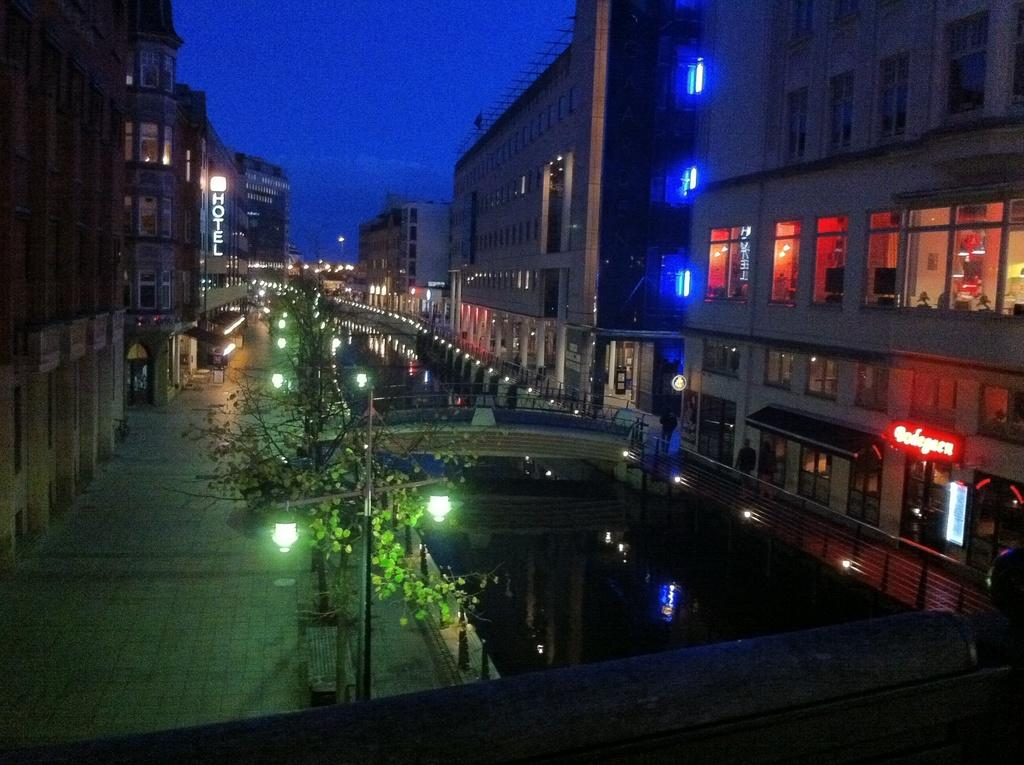What type of structures can be seen in the image? There are buildings in the image. What natural element is visible in the image? There is water visible in the image. What type of vegetation is present in the image? There are trees in the image. Can you describe a man-made object in the image? There is a pole in the image. What type of signage is present in the image? There are boards in the image. What type of illumination is present in the image? There are lights in the image. What type of infrastructure is present in the image? There is a bridge in the image. What is the color of the sky in the image? The sky is blue in the image. What type of barrier is present in the image? There is a railing in the image. What general category of items can be seen in the image? There are objects in the image. Can you describe the people in the image? There are two people in front of a building. How many beds can be seen in the image? There are no beds present in the image. What type of activity are the people in the image engaged in? The provided facts do not mention any specific activity the people are engaged in. Is there a brother present in the image? The provided facts do not mention any siblings or family relationships. 